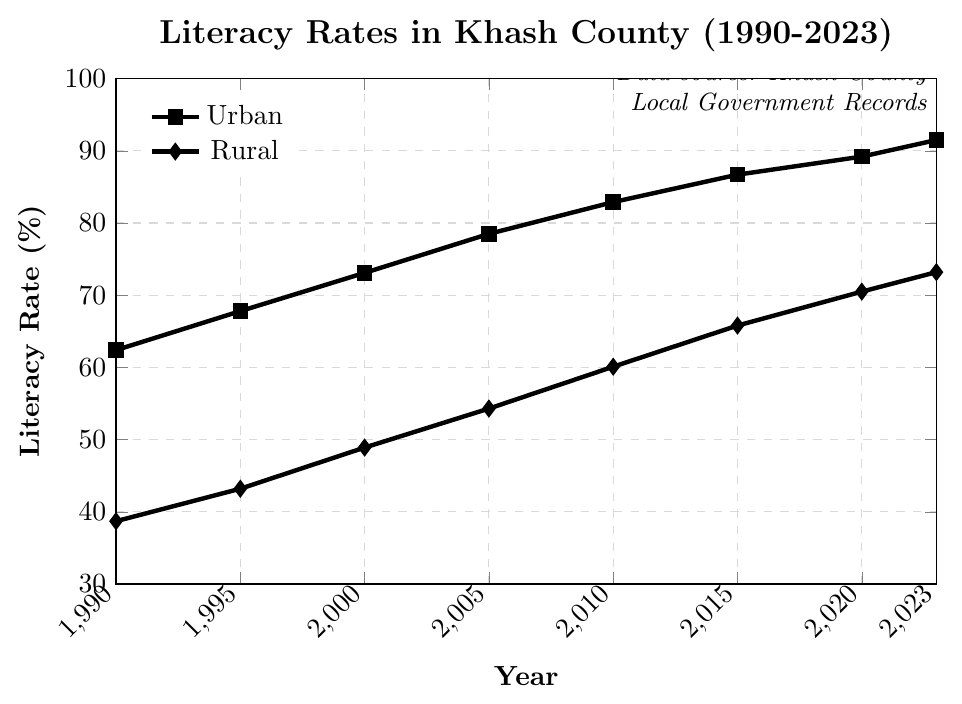What is the literacy rate for urban areas in 2023? The urban literacy rate for 2023 can be found at the end point of the urban line plot.
Answer: 91.5% What is the difference in literacy rates between urban and rural areas in 1990? The urban literacy rate in 1990 is 62.4%, and the rural literacy rate is 38.7%. The difference is 62.4 - 38.7 = 23.7%.
Answer: 23.7% Which year shows the smallest gap between urban and rural literacy rates, and what is that gap? Calculate the differences for each year: 
(1990: 23.7, 1995: 24.6, 2000: 24.2, 2005: 24.2, 2010: 22.8, 2015: 20.9, 2020: 18.7, 2023: 18.3). The smallest gap, 18.3%, occurs in 2023.
Answer: 2023, 18.3% How did the literacy rate for rural areas change from 2000 to 2015? The rural literacy rate in 2000 was 48.9% and increased to 65.8% by 2015. The change is 65.8% - 48.9% = 16.9%.
Answer: 16.9% In which year did the urban literacy rate exceed 80%? Identify the year when the urban rate first exceeded 80%, which is visible from the plot. This happens between 2005 (78.5%) and 2010 (82.9%). Hence, it is in 2010.
Answer: 2010 By how much has the rural literacy rate increased from 1990 to 2023? Subtract the rural literacy rate in 1990 (38.7%) from the rate in 2023 (73.2%). The increase is 73.2 - 38.7 = 34.5%.
Answer: 34.5% What is the average urban literacy rate from 1990 to 2023? Calculate the average by summing the urban rates (62.4 + 67.8 + 73.1 + 78.5 + 82.9 + 86.7 + 89.2 + 91.5) and dividing by the number of years (8). The average is (62.4 + 67.8 + 73.1 + 78.5 + 82.9 + 86.7 + 89.2 + 91.5)/8 = 78.9%.
Answer: 78.9% Between which consecutive years did the urban literacy rate see the largest increase? Calculate the differences between consecutive years: 
(1990-1995: 5.4, 1995-2000: 5.3, 2000-2005: 5.4, 2005-2010: 4.4, 2010-2015: 3.8, 2015-2020: 2.5, 2020-2023: 2.3). The largest increase is 5.4%, occurring from 1990-1995 and 2000-2005.
Answer: 1990-1995 and 2000-2005, 5.4% What trends can be observed for literacy rates in urban and rural areas from 1990 to 2023? The literacy rates in both urban and rural areas show an increasing trend over time. Urban areas have consistently higher rates than rural areas, and the gap between them, while fluctuating, generally decreases over time.
Answer: Increasing trends in both areas; narrowing gap 